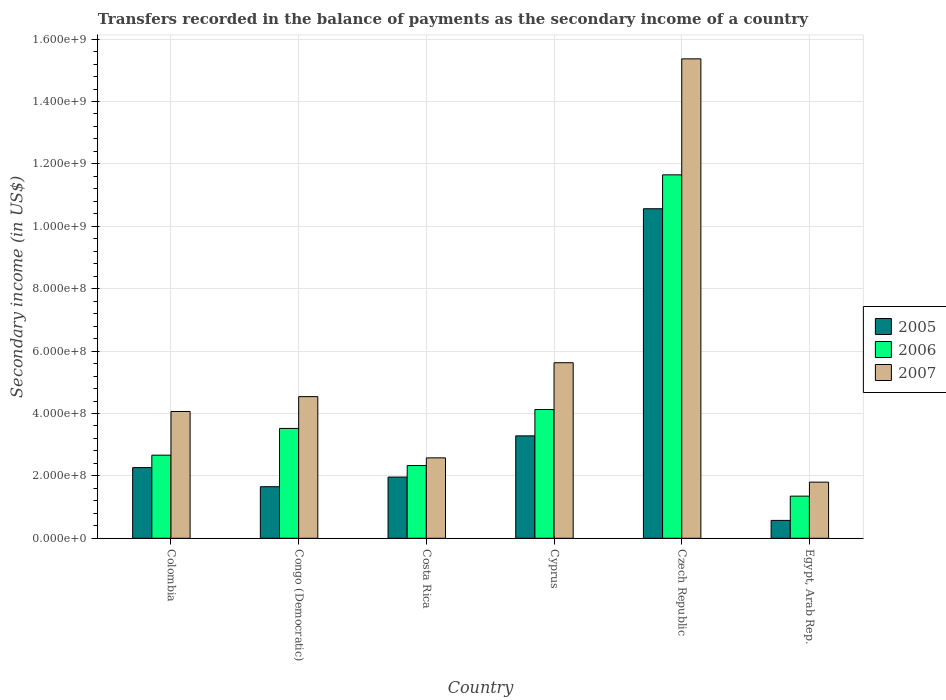How many different coloured bars are there?
Your answer should be very brief. 3. Are the number of bars per tick equal to the number of legend labels?
Your answer should be very brief. Yes. How many bars are there on the 4th tick from the right?
Keep it short and to the point. 3. What is the label of the 5th group of bars from the left?
Provide a short and direct response. Czech Republic. In how many cases, is the number of bars for a given country not equal to the number of legend labels?
Give a very brief answer. 0. What is the secondary income of in 2006 in Congo (Democratic)?
Your answer should be compact. 3.52e+08. Across all countries, what is the maximum secondary income of in 2005?
Provide a short and direct response. 1.06e+09. Across all countries, what is the minimum secondary income of in 2007?
Your answer should be compact. 1.80e+08. In which country was the secondary income of in 2005 maximum?
Offer a very short reply. Czech Republic. In which country was the secondary income of in 2006 minimum?
Keep it short and to the point. Egypt, Arab Rep. What is the total secondary income of in 2006 in the graph?
Give a very brief answer. 2.56e+09. What is the difference between the secondary income of in 2005 in Congo (Democratic) and that in Costa Rica?
Offer a very short reply. -3.09e+07. What is the difference between the secondary income of in 2006 in Congo (Democratic) and the secondary income of in 2005 in Czech Republic?
Provide a succinct answer. -7.04e+08. What is the average secondary income of in 2005 per country?
Offer a terse response. 3.38e+08. What is the difference between the secondary income of of/in 2005 and secondary income of of/in 2006 in Costa Rica?
Give a very brief answer. -3.69e+07. What is the ratio of the secondary income of in 2007 in Congo (Democratic) to that in Costa Rica?
Keep it short and to the point. 1.76. Is the secondary income of in 2007 in Colombia less than that in Cyprus?
Your answer should be compact. Yes. What is the difference between the highest and the second highest secondary income of in 2005?
Offer a terse response. -8.30e+08. What is the difference between the highest and the lowest secondary income of in 2005?
Give a very brief answer. 9.99e+08. In how many countries, is the secondary income of in 2007 greater than the average secondary income of in 2007 taken over all countries?
Keep it short and to the point. 1. Is the sum of the secondary income of in 2007 in Czech Republic and Egypt, Arab Rep. greater than the maximum secondary income of in 2006 across all countries?
Your response must be concise. Yes. What does the 3rd bar from the right in Czech Republic represents?
Your answer should be compact. 2005. Is it the case that in every country, the sum of the secondary income of in 2005 and secondary income of in 2007 is greater than the secondary income of in 2006?
Offer a very short reply. Yes. Are all the bars in the graph horizontal?
Make the answer very short. No. How many countries are there in the graph?
Offer a terse response. 6. What is the difference between two consecutive major ticks on the Y-axis?
Your response must be concise. 2.00e+08. Does the graph contain any zero values?
Your answer should be compact. No. What is the title of the graph?
Ensure brevity in your answer.  Transfers recorded in the balance of payments as the secondary income of a country. Does "1995" appear as one of the legend labels in the graph?
Provide a short and direct response. No. What is the label or title of the Y-axis?
Your answer should be compact. Secondary income (in US$). What is the Secondary income (in US$) in 2005 in Colombia?
Give a very brief answer. 2.27e+08. What is the Secondary income (in US$) of 2006 in Colombia?
Ensure brevity in your answer.  2.66e+08. What is the Secondary income (in US$) of 2007 in Colombia?
Offer a very short reply. 4.06e+08. What is the Secondary income (in US$) in 2005 in Congo (Democratic)?
Ensure brevity in your answer.  1.65e+08. What is the Secondary income (in US$) in 2006 in Congo (Democratic)?
Provide a succinct answer. 3.52e+08. What is the Secondary income (in US$) of 2007 in Congo (Democratic)?
Ensure brevity in your answer.  4.54e+08. What is the Secondary income (in US$) in 2005 in Costa Rica?
Offer a very short reply. 1.96e+08. What is the Secondary income (in US$) in 2006 in Costa Rica?
Ensure brevity in your answer.  2.33e+08. What is the Secondary income (in US$) of 2007 in Costa Rica?
Your response must be concise. 2.58e+08. What is the Secondary income (in US$) in 2005 in Cyprus?
Ensure brevity in your answer.  3.28e+08. What is the Secondary income (in US$) of 2006 in Cyprus?
Ensure brevity in your answer.  4.13e+08. What is the Secondary income (in US$) of 2007 in Cyprus?
Your response must be concise. 5.63e+08. What is the Secondary income (in US$) in 2005 in Czech Republic?
Provide a short and direct response. 1.06e+09. What is the Secondary income (in US$) of 2006 in Czech Republic?
Provide a succinct answer. 1.16e+09. What is the Secondary income (in US$) of 2007 in Czech Republic?
Offer a very short reply. 1.54e+09. What is the Secondary income (in US$) of 2005 in Egypt, Arab Rep.?
Your answer should be compact. 5.73e+07. What is the Secondary income (in US$) in 2006 in Egypt, Arab Rep.?
Provide a succinct answer. 1.35e+08. What is the Secondary income (in US$) in 2007 in Egypt, Arab Rep.?
Provide a short and direct response. 1.80e+08. Across all countries, what is the maximum Secondary income (in US$) in 2005?
Your answer should be compact. 1.06e+09. Across all countries, what is the maximum Secondary income (in US$) of 2006?
Your answer should be compact. 1.16e+09. Across all countries, what is the maximum Secondary income (in US$) of 2007?
Your answer should be very brief. 1.54e+09. Across all countries, what is the minimum Secondary income (in US$) in 2005?
Provide a short and direct response. 5.73e+07. Across all countries, what is the minimum Secondary income (in US$) of 2006?
Keep it short and to the point. 1.35e+08. Across all countries, what is the minimum Secondary income (in US$) in 2007?
Give a very brief answer. 1.80e+08. What is the total Secondary income (in US$) of 2005 in the graph?
Offer a very short reply. 2.03e+09. What is the total Secondary income (in US$) of 2006 in the graph?
Your answer should be compact. 2.56e+09. What is the total Secondary income (in US$) in 2007 in the graph?
Your response must be concise. 3.40e+09. What is the difference between the Secondary income (in US$) of 2005 in Colombia and that in Congo (Democratic)?
Offer a terse response. 6.12e+07. What is the difference between the Secondary income (in US$) in 2006 in Colombia and that in Congo (Democratic)?
Make the answer very short. -8.57e+07. What is the difference between the Secondary income (in US$) of 2007 in Colombia and that in Congo (Democratic)?
Keep it short and to the point. -4.76e+07. What is the difference between the Secondary income (in US$) of 2005 in Colombia and that in Costa Rica?
Your answer should be compact. 3.04e+07. What is the difference between the Secondary income (in US$) in 2006 in Colombia and that in Costa Rica?
Your response must be concise. 3.33e+07. What is the difference between the Secondary income (in US$) of 2007 in Colombia and that in Costa Rica?
Your answer should be very brief. 1.49e+08. What is the difference between the Secondary income (in US$) of 2005 in Colombia and that in Cyprus?
Give a very brief answer. -1.02e+08. What is the difference between the Secondary income (in US$) in 2006 in Colombia and that in Cyprus?
Provide a short and direct response. -1.46e+08. What is the difference between the Secondary income (in US$) of 2007 in Colombia and that in Cyprus?
Provide a succinct answer. -1.56e+08. What is the difference between the Secondary income (in US$) in 2005 in Colombia and that in Czech Republic?
Your answer should be compact. -8.30e+08. What is the difference between the Secondary income (in US$) in 2006 in Colombia and that in Czech Republic?
Offer a very short reply. -8.99e+08. What is the difference between the Secondary income (in US$) in 2007 in Colombia and that in Czech Republic?
Offer a very short reply. -1.13e+09. What is the difference between the Secondary income (in US$) in 2005 in Colombia and that in Egypt, Arab Rep.?
Keep it short and to the point. 1.69e+08. What is the difference between the Secondary income (in US$) of 2006 in Colombia and that in Egypt, Arab Rep.?
Give a very brief answer. 1.31e+08. What is the difference between the Secondary income (in US$) of 2007 in Colombia and that in Egypt, Arab Rep.?
Your answer should be very brief. 2.26e+08. What is the difference between the Secondary income (in US$) in 2005 in Congo (Democratic) and that in Costa Rica?
Give a very brief answer. -3.09e+07. What is the difference between the Secondary income (in US$) of 2006 in Congo (Democratic) and that in Costa Rica?
Offer a terse response. 1.19e+08. What is the difference between the Secondary income (in US$) in 2007 in Congo (Democratic) and that in Costa Rica?
Make the answer very short. 1.96e+08. What is the difference between the Secondary income (in US$) in 2005 in Congo (Democratic) and that in Cyprus?
Provide a succinct answer. -1.63e+08. What is the difference between the Secondary income (in US$) of 2006 in Congo (Democratic) and that in Cyprus?
Provide a short and direct response. -6.06e+07. What is the difference between the Secondary income (in US$) in 2007 in Congo (Democratic) and that in Cyprus?
Your response must be concise. -1.09e+08. What is the difference between the Secondary income (in US$) in 2005 in Congo (Democratic) and that in Czech Republic?
Make the answer very short. -8.91e+08. What is the difference between the Secondary income (in US$) of 2006 in Congo (Democratic) and that in Czech Republic?
Provide a short and direct response. -8.13e+08. What is the difference between the Secondary income (in US$) of 2007 in Congo (Democratic) and that in Czech Republic?
Offer a very short reply. -1.08e+09. What is the difference between the Secondary income (in US$) of 2005 in Congo (Democratic) and that in Egypt, Arab Rep.?
Make the answer very short. 1.08e+08. What is the difference between the Secondary income (in US$) of 2006 in Congo (Democratic) and that in Egypt, Arab Rep.?
Give a very brief answer. 2.17e+08. What is the difference between the Secondary income (in US$) of 2007 in Congo (Democratic) and that in Egypt, Arab Rep.?
Make the answer very short. 2.74e+08. What is the difference between the Secondary income (in US$) in 2005 in Costa Rica and that in Cyprus?
Provide a short and direct response. -1.32e+08. What is the difference between the Secondary income (in US$) of 2006 in Costa Rica and that in Cyprus?
Offer a very short reply. -1.80e+08. What is the difference between the Secondary income (in US$) of 2007 in Costa Rica and that in Cyprus?
Keep it short and to the point. -3.05e+08. What is the difference between the Secondary income (in US$) in 2005 in Costa Rica and that in Czech Republic?
Give a very brief answer. -8.60e+08. What is the difference between the Secondary income (in US$) in 2006 in Costa Rica and that in Czech Republic?
Provide a succinct answer. -9.32e+08. What is the difference between the Secondary income (in US$) in 2007 in Costa Rica and that in Czech Republic?
Provide a succinct answer. -1.28e+09. What is the difference between the Secondary income (in US$) of 2005 in Costa Rica and that in Egypt, Arab Rep.?
Offer a very short reply. 1.39e+08. What is the difference between the Secondary income (in US$) of 2006 in Costa Rica and that in Egypt, Arab Rep.?
Ensure brevity in your answer.  9.80e+07. What is the difference between the Secondary income (in US$) of 2007 in Costa Rica and that in Egypt, Arab Rep.?
Give a very brief answer. 7.79e+07. What is the difference between the Secondary income (in US$) in 2005 in Cyprus and that in Czech Republic?
Your answer should be compact. -7.28e+08. What is the difference between the Secondary income (in US$) in 2006 in Cyprus and that in Czech Republic?
Your answer should be compact. -7.52e+08. What is the difference between the Secondary income (in US$) of 2007 in Cyprus and that in Czech Republic?
Make the answer very short. -9.74e+08. What is the difference between the Secondary income (in US$) of 2005 in Cyprus and that in Egypt, Arab Rep.?
Offer a very short reply. 2.71e+08. What is the difference between the Secondary income (in US$) of 2006 in Cyprus and that in Egypt, Arab Rep.?
Provide a succinct answer. 2.78e+08. What is the difference between the Secondary income (in US$) in 2007 in Cyprus and that in Egypt, Arab Rep.?
Provide a succinct answer. 3.83e+08. What is the difference between the Secondary income (in US$) of 2005 in Czech Republic and that in Egypt, Arab Rep.?
Your response must be concise. 9.99e+08. What is the difference between the Secondary income (in US$) in 2006 in Czech Republic and that in Egypt, Arab Rep.?
Give a very brief answer. 1.03e+09. What is the difference between the Secondary income (in US$) of 2007 in Czech Republic and that in Egypt, Arab Rep.?
Offer a very short reply. 1.36e+09. What is the difference between the Secondary income (in US$) of 2005 in Colombia and the Secondary income (in US$) of 2006 in Congo (Democratic)?
Your answer should be very brief. -1.26e+08. What is the difference between the Secondary income (in US$) in 2005 in Colombia and the Secondary income (in US$) in 2007 in Congo (Democratic)?
Offer a very short reply. -2.27e+08. What is the difference between the Secondary income (in US$) of 2006 in Colombia and the Secondary income (in US$) of 2007 in Congo (Democratic)?
Provide a succinct answer. -1.88e+08. What is the difference between the Secondary income (in US$) of 2005 in Colombia and the Secondary income (in US$) of 2006 in Costa Rica?
Offer a very short reply. -6.56e+06. What is the difference between the Secondary income (in US$) of 2005 in Colombia and the Secondary income (in US$) of 2007 in Costa Rica?
Keep it short and to the point. -3.12e+07. What is the difference between the Secondary income (in US$) in 2006 in Colombia and the Secondary income (in US$) in 2007 in Costa Rica?
Give a very brief answer. 8.60e+06. What is the difference between the Secondary income (in US$) of 2005 in Colombia and the Secondary income (in US$) of 2006 in Cyprus?
Your response must be concise. -1.86e+08. What is the difference between the Secondary income (in US$) in 2005 in Colombia and the Secondary income (in US$) in 2007 in Cyprus?
Your answer should be very brief. -3.36e+08. What is the difference between the Secondary income (in US$) in 2006 in Colombia and the Secondary income (in US$) in 2007 in Cyprus?
Keep it short and to the point. -2.96e+08. What is the difference between the Secondary income (in US$) in 2005 in Colombia and the Secondary income (in US$) in 2006 in Czech Republic?
Offer a terse response. -9.38e+08. What is the difference between the Secondary income (in US$) of 2005 in Colombia and the Secondary income (in US$) of 2007 in Czech Republic?
Your answer should be very brief. -1.31e+09. What is the difference between the Secondary income (in US$) in 2006 in Colombia and the Secondary income (in US$) in 2007 in Czech Republic?
Ensure brevity in your answer.  -1.27e+09. What is the difference between the Secondary income (in US$) in 2005 in Colombia and the Secondary income (in US$) in 2006 in Egypt, Arab Rep.?
Give a very brief answer. 9.14e+07. What is the difference between the Secondary income (in US$) of 2005 in Colombia and the Secondary income (in US$) of 2007 in Egypt, Arab Rep.?
Provide a short and direct response. 4.66e+07. What is the difference between the Secondary income (in US$) in 2006 in Colombia and the Secondary income (in US$) in 2007 in Egypt, Arab Rep.?
Provide a succinct answer. 8.65e+07. What is the difference between the Secondary income (in US$) of 2005 in Congo (Democratic) and the Secondary income (in US$) of 2006 in Costa Rica?
Your answer should be very brief. -6.78e+07. What is the difference between the Secondary income (in US$) of 2005 in Congo (Democratic) and the Secondary income (in US$) of 2007 in Costa Rica?
Make the answer very short. -9.25e+07. What is the difference between the Secondary income (in US$) in 2006 in Congo (Democratic) and the Secondary income (in US$) in 2007 in Costa Rica?
Offer a terse response. 9.43e+07. What is the difference between the Secondary income (in US$) in 2005 in Congo (Democratic) and the Secondary income (in US$) in 2006 in Cyprus?
Your answer should be compact. -2.47e+08. What is the difference between the Secondary income (in US$) of 2005 in Congo (Democratic) and the Secondary income (in US$) of 2007 in Cyprus?
Ensure brevity in your answer.  -3.97e+08. What is the difference between the Secondary income (in US$) in 2006 in Congo (Democratic) and the Secondary income (in US$) in 2007 in Cyprus?
Provide a short and direct response. -2.11e+08. What is the difference between the Secondary income (in US$) of 2005 in Congo (Democratic) and the Secondary income (in US$) of 2006 in Czech Republic?
Provide a short and direct response. -1.00e+09. What is the difference between the Secondary income (in US$) of 2005 in Congo (Democratic) and the Secondary income (in US$) of 2007 in Czech Republic?
Keep it short and to the point. -1.37e+09. What is the difference between the Secondary income (in US$) of 2006 in Congo (Democratic) and the Secondary income (in US$) of 2007 in Czech Republic?
Your answer should be very brief. -1.18e+09. What is the difference between the Secondary income (in US$) of 2005 in Congo (Democratic) and the Secondary income (in US$) of 2006 in Egypt, Arab Rep.?
Your response must be concise. 3.02e+07. What is the difference between the Secondary income (in US$) of 2005 in Congo (Democratic) and the Secondary income (in US$) of 2007 in Egypt, Arab Rep.?
Give a very brief answer. -1.46e+07. What is the difference between the Secondary income (in US$) in 2006 in Congo (Democratic) and the Secondary income (in US$) in 2007 in Egypt, Arab Rep.?
Make the answer very short. 1.72e+08. What is the difference between the Secondary income (in US$) of 2005 in Costa Rica and the Secondary income (in US$) of 2006 in Cyprus?
Keep it short and to the point. -2.17e+08. What is the difference between the Secondary income (in US$) of 2005 in Costa Rica and the Secondary income (in US$) of 2007 in Cyprus?
Offer a terse response. -3.67e+08. What is the difference between the Secondary income (in US$) of 2006 in Costa Rica and the Secondary income (in US$) of 2007 in Cyprus?
Your answer should be compact. -3.30e+08. What is the difference between the Secondary income (in US$) of 2005 in Costa Rica and the Secondary income (in US$) of 2006 in Czech Republic?
Give a very brief answer. -9.69e+08. What is the difference between the Secondary income (in US$) of 2005 in Costa Rica and the Secondary income (in US$) of 2007 in Czech Republic?
Your answer should be very brief. -1.34e+09. What is the difference between the Secondary income (in US$) in 2006 in Costa Rica and the Secondary income (in US$) in 2007 in Czech Republic?
Your answer should be compact. -1.30e+09. What is the difference between the Secondary income (in US$) in 2005 in Costa Rica and the Secondary income (in US$) in 2006 in Egypt, Arab Rep.?
Ensure brevity in your answer.  6.11e+07. What is the difference between the Secondary income (in US$) in 2005 in Costa Rica and the Secondary income (in US$) in 2007 in Egypt, Arab Rep.?
Make the answer very short. 1.63e+07. What is the difference between the Secondary income (in US$) of 2006 in Costa Rica and the Secondary income (in US$) of 2007 in Egypt, Arab Rep.?
Give a very brief answer. 5.32e+07. What is the difference between the Secondary income (in US$) of 2005 in Cyprus and the Secondary income (in US$) of 2006 in Czech Republic?
Make the answer very short. -8.37e+08. What is the difference between the Secondary income (in US$) in 2005 in Cyprus and the Secondary income (in US$) in 2007 in Czech Republic?
Your response must be concise. -1.21e+09. What is the difference between the Secondary income (in US$) in 2006 in Cyprus and the Secondary income (in US$) in 2007 in Czech Republic?
Your answer should be very brief. -1.12e+09. What is the difference between the Secondary income (in US$) of 2005 in Cyprus and the Secondary income (in US$) of 2006 in Egypt, Arab Rep.?
Your answer should be very brief. 1.93e+08. What is the difference between the Secondary income (in US$) of 2005 in Cyprus and the Secondary income (in US$) of 2007 in Egypt, Arab Rep.?
Make the answer very short. 1.48e+08. What is the difference between the Secondary income (in US$) of 2006 in Cyprus and the Secondary income (in US$) of 2007 in Egypt, Arab Rep.?
Ensure brevity in your answer.  2.33e+08. What is the difference between the Secondary income (in US$) in 2005 in Czech Republic and the Secondary income (in US$) in 2006 in Egypt, Arab Rep.?
Ensure brevity in your answer.  9.21e+08. What is the difference between the Secondary income (in US$) of 2005 in Czech Republic and the Secondary income (in US$) of 2007 in Egypt, Arab Rep.?
Your answer should be very brief. 8.76e+08. What is the difference between the Secondary income (in US$) in 2006 in Czech Republic and the Secondary income (in US$) in 2007 in Egypt, Arab Rep.?
Give a very brief answer. 9.85e+08. What is the average Secondary income (in US$) in 2005 per country?
Your answer should be compact. 3.38e+08. What is the average Secondary income (in US$) in 2006 per country?
Keep it short and to the point. 4.27e+08. What is the average Secondary income (in US$) of 2007 per country?
Provide a succinct answer. 5.66e+08. What is the difference between the Secondary income (in US$) of 2005 and Secondary income (in US$) of 2006 in Colombia?
Ensure brevity in your answer.  -3.98e+07. What is the difference between the Secondary income (in US$) of 2005 and Secondary income (in US$) of 2007 in Colombia?
Provide a succinct answer. -1.80e+08. What is the difference between the Secondary income (in US$) of 2006 and Secondary income (in US$) of 2007 in Colombia?
Offer a very short reply. -1.40e+08. What is the difference between the Secondary income (in US$) in 2005 and Secondary income (in US$) in 2006 in Congo (Democratic)?
Your response must be concise. -1.87e+08. What is the difference between the Secondary income (in US$) in 2005 and Secondary income (in US$) in 2007 in Congo (Democratic)?
Make the answer very short. -2.89e+08. What is the difference between the Secondary income (in US$) in 2006 and Secondary income (in US$) in 2007 in Congo (Democratic)?
Provide a succinct answer. -1.02e+08. What is the difference between the Secondary income (in US$) in 2005 and Secondary income (in US$) in 2006 in Costa Rica?
Keep it short and to the point. -3.69e+07. What is the difference between the Secondary income (in US$) of 2005 and Secondary income (in US$) of 2007 in Costa Rica?
Offer a very short reply. -6.16e+07. What is the difference between the Secondary income (in US$) of 2006 and Secondary income (in US$) of 2007 in Costa Rica?
Offer a terse response. -2.47e+07. What is the difference between the Secondary income (in US$) of 2005 and Secondary income (in US$) of 2006 in Cyprus?
Your response must be concise. -8.44e+07. What is the difference between the Secondary income (in US$) in 2005 and Secondary income (in US$) in 2007 in Cyprus?
Provide a succinct answer. -2.34e+08. What is the difference between the Secondary income (in US$) of 2006 and Secondary income (in US$) of 2007 in Cyprus?
Ensure brevity in your answer.  -1.50e+08. What is the difference between the Secondary income (in US$) of 2005 and Secondary income (in US$) of 2006 in Czech Republic?
Ensure brevity in your answer.  -1.09e+08. What is the difference between the Secondary income (in US$) in 2005 and Secondary income (in US$) in 2007 in Czech Republic?
Keep it short and to the point. -4.80e+08. What is the difference between the Secondary income (in US$) in 2006 and Secondary income (in US$) in 2007 in Czech Republic?
Offer a terse response. -3.72e+08. What is the difference between the Secondary income (in US$) in 2005 and Secondary income (in US$) in 2006 in Egypt, Arab Rep.?
Your response must be concise. -7.78e+07. What is the difference between the Secondary income (in US$) in 2005 and Secondary income (in US$) in 2007 in Egypt, Arab Rep.?
Your response must be concise. -1.23e+08. What is the difference between the Secondary income (in US$) in 2006 and Secondary income (in US$) in 2007 in Egypt, Arab Rep.?
Your answer should be compact. -4.48e+07. What is the ratio of the Secondary income (in US$) in 2005 in Colombia to that in Congo (Democratic)?
Provide a succinct answer. 1.37. What is the ratio of the Secondary income (in US$) of 2006 in Colombia to that in Congo (Democratic)?
Your response must be concise. 0.76. What is the ratio of the Secondary income (in US$) in 2007 in Colombia to that in Congo (Democratic)?
Make the answer very short. 0.9. What is the ratio of the Secondary income (in US$) in 2005 in Colombia to that in Costa Rica?
Your answer should be very brief. 1.15. What is the ratio of the Secondary income (in US$) in 2006 in Colombia to that in Costa Rica?
Your response must be concise. 1.14. What is the ratio of the Secondary income (in US$) in 2007 in Colombia to that in Costa Rica?
Keep it short and to the point. 1.58. What is the ratio of the Secondary income (in US$) in 2005 in Colombia to that in Cyprus?
Offer a very short reply. 0.69. What is the ratio of the Secondary income (in US$) in 2006 in Colombia to that in Cyprus?
Provide a short and direct response. 0.65. What is the ratio of the Secondary income (in US$) in 2007 in Colombia to that in Cyprus?
Offer a very short reply. 0.72. What is the ratio of the Secondary income (in US$) of 2005 in Colombia to that in Czech Republic?
Offer a very short reply. 0.21. What is the ratio of the Secondary income (in US$) of 2006 in Colombia to that in Czech Republic?
Offer a terse response. 0.23. What is the ratio of the Secondary income (in US$) of 2007 in Colombia to that in Czech Republic?
Your answer should be very brief. 0.26. What is the ratio of the Secondary income (in US$) in 2005 in Colombia to that in Egypt, Arab Rep.?
Provide a short and direct response. 3.95. What is the ratio of the Secondary income (in US$) of 2006 in Colombia to that in Egypt, Arab Rep.?
Give a very brief answer. 1.97. What is the ratio of the Secondary income (in US$) in 2007 in Colombia to that in Egypt, Arab Rep.?
Your answer should be compact. 2.26. What is the ratio of the Secondary income (in US$) of 2005 in Congo (Democratic) to that in Costa Rica?
Ensure brevity in your answer.  0.84. What is the ratio of the Secondary income (in US$) in 2006 in Congo (Democratic) to that in Costa Rica?
Keep it short and to the point. 1.51. What is the ratio of the Secondary income (in US$) in 2007 in Congo (Democratic) to that in Costa Rica?
Offer a terse response. 1.76. What is the ratio of the Secondary income (in US$) of 2005 in Congo (Democratic) to that in Cyprus?
Your response must be concise. 0.5. What is the ratio of the Secondary income (in US$) of 2006 in Congo (Democratic) to that in Cyprus?
Give a very brief answer. 0.85. What is the ratio of the Secondary income (in US$) of 2007 in Congo (Democratic) to that in Cyprus?
Give a very brief answer. 0.81. What is the ratio of the Secondary income (in US$) in 2005 in Congo (Democratic) to that in Czech Republic?
Make the answer very short. 0.16. What is the ratio of the Secondary income (in US$) of 2006 in Congo (Democratic) to that in Czech Republic?
Your answer should be compact. 0.3. What is the ratio of the Secondary income (in US$) of 2007 in Congo (Democratic) to that in Czech Republic?
Your response must be concise. 0.3. What is the ratio of the Secondary income (in US$) in 2005 in Congo (Democratic) to that in Egypt, Arab Rep.?
Keep it short and to the point. 2.88. What is the ratio of the Secondary income (in US$) of 2006 in Congo (Democratic) to that in Egypt, Arab Rep.?
Your answer should be compact. 2.61. What is the ratio of the Secondary income (in US$) in 2007 in Congo (Democratic) to that in Egypt, Arab Rep.?
Ensure brevity in your answer.  2.52. What is the ratio of the Secondary income (in US$) in 2005 in Costa Rica to that in Cyprus?
Your answer should be very brief. 0.6. What is the ratio of the Secondary income (in US$) in 2006 in Costa Rica to that in Cyprus?
Your response must be concise. 0.56. What is the ratio of the Secondary income (in US$) in 2007 in Costa Rica to that in Cyprus?
Provide a succinct answer. 0.46. What is the ratio of the Secondary income (in US$) in 2005 in Costa Rica to that in Czech Republic?
Your answer should be compact. 0.19. What is the ratio of the Secondary income (in US$) in 2006 in Costa Rica to that in Czech Republic?
Your answer should be compact. 0.2. What is the ratio of the Secondary income (in US$) of 2007 in Costa Rica to that in Czech Republic?
Provide a succinct answer. 0.17. What is the ratio of the Secondary income (in US$) in 2005 in Costa Rica to that in Egypt, Arab Rep.?
Offer a terse response. 3.42. What is the ratio of the Secondary income (in US$) of 2006 in Costa Rica to that in Egypt, Arab Rep.?
Make the answer very short. 1.73. What is the ratio of the Secondary income (in US$) of 2007 in Costa Rica to that in Egypt, Arab Rep.?
Your response must be concise. 1.43. What is the ratio of the Secondary income (in US$) in 2005 in Cyprus to that in Czech Republic?
Offer a very short reply. 0.31. What is the ratio of the Secondary income (in US$) of 2006 in Cyprus to that in Czech Republic?
Make the answer very short. 0.35. What is the ratio of the Secondary income (in US$) of 2007 in Cyprus to that in Czech Republic?
Keep it short and to the point. 0.37. What is the ratio of the Secondary income (in US$) in 2005 in Cyprus to that in Egypt, Arab Rep.?
Your response must be concise. 5.73. What is the ratio of the Secondary income (in US$) in 2006 in Cyprus to that in Egypt, Arab Rep.?
Provide a succinct answer. 3.05. What is the ratio of the Secondary income (in US$) of 2007 in Cyprus to that in Egypt, Arab Rep.?
Provide a short and direct response. 3.13. What is the ratio of the Secondary income (in US$) in 2005 in Czech Republic to that in Egypt, Arab Rep.?
Your answer should be compact. 18.43. What is the ratio of the Secondary income (in US$) of 2006 in Czech Republic to that in Egypt, Arab Rep.?
Make the answer very short. 8.62. What is the ratio of the Secondary income (in US$) of 2007 in Czech Republic to that in Egypt, Arab Rep.?
Give a very brief answer. 8.54. What is the difference between the highest and the second highest Secondary income (in US$) in 2005?
Make the answer very short. 7.28e+08. What is the difference between the highest and the second highest Secondary income (in US$) in 2006?
Your response must be concise. 7.52e+08. What is the difference between the highest and the second highest Secondary income (in US$) in 2007?
Your response must be concise. 9.74e+08. What is the difference between the highest and the lowest Secondary income (in US$) in 2005?
Offer a terse response. 9.99e+08. What is the difference between the highest and the lowest Secondary income (in US$) of 2006?
Give a very brief answer. 1.03e+09. What is the difference between the highest and the lowest Secondary income (in US$) of 2007?
Give a very brief answer. 1.36e+09. 